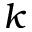<formula> <loc_0><loc_0><loc_500><loc_500>k</formula> 